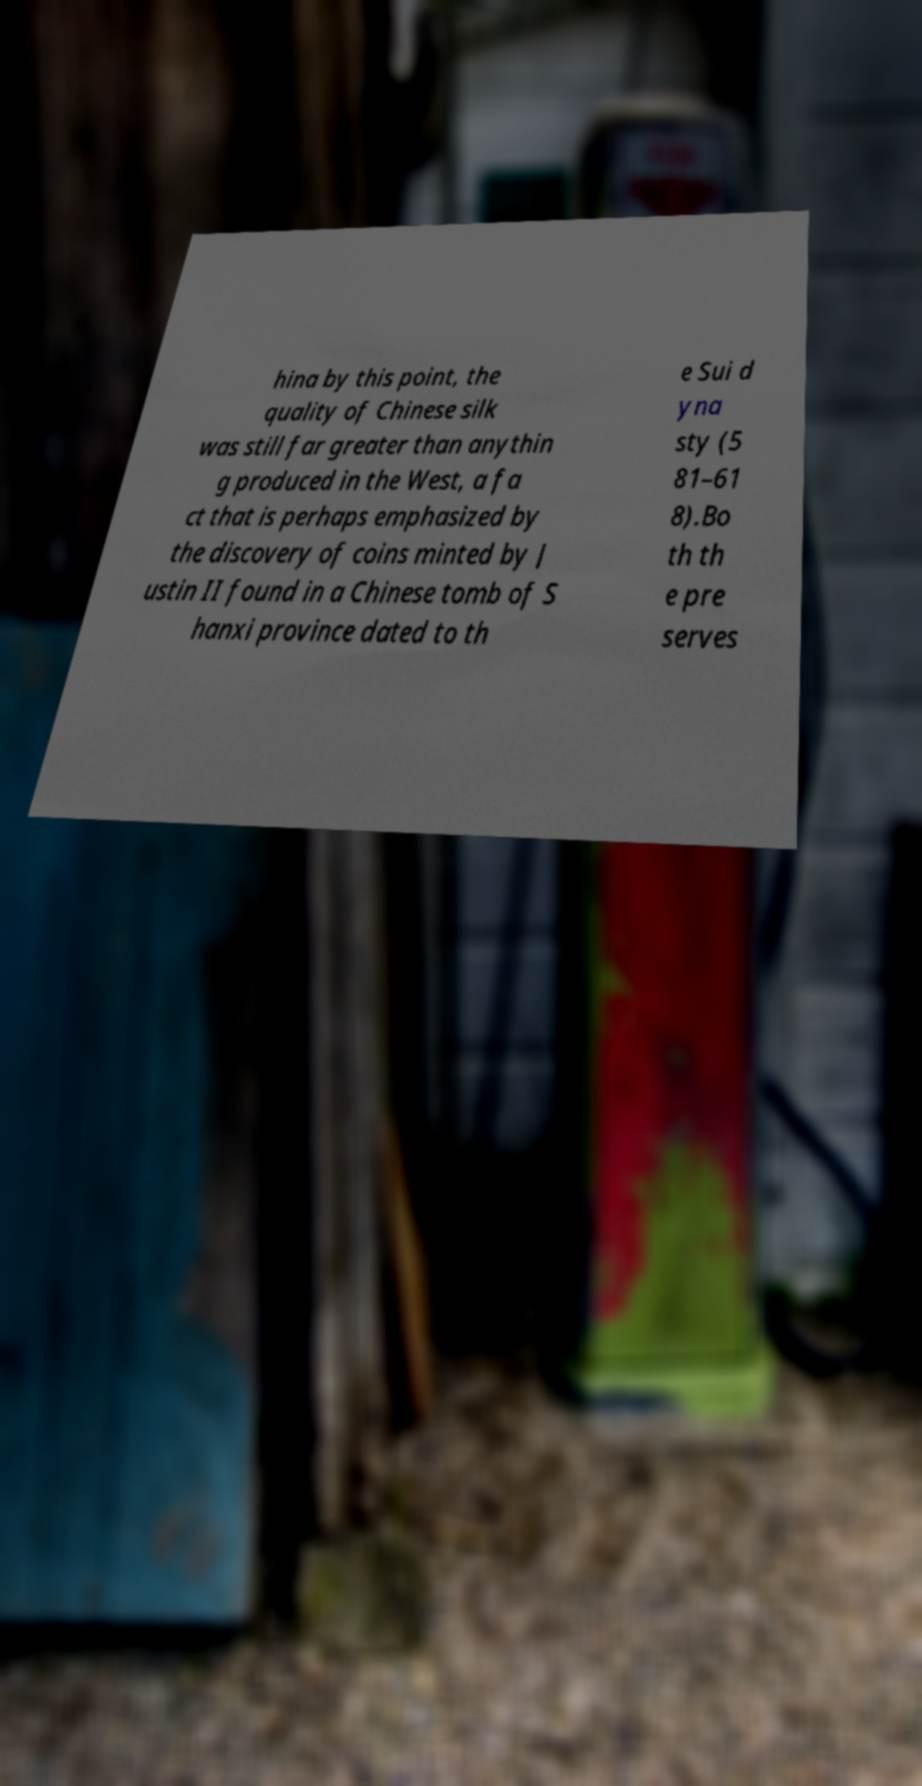Could you extract and type out the text from this image? hina by this point, the quality of Chinese silk was still far greater than anythin g produced in the West, a fa ct that is perhaps emphasized by the discovery of coins minted by J ustin II found in a Chinese tomb of S hanxi province dated to th e Sui d yna sty (5 81–61 8).Bo th th e pre serves 